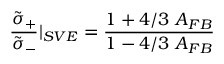Convert formula to latex. <formula><loc_0><loc_0><loc_500><loc_500>{ \frac { \tilde { \sigma } _ { + } } { \tilde { \sigma } _ { - } } } | _ { S V E } = { \frac { 1 + 4 / 3 \ A _ { F B } } { 1 - 4 / 3 \ A _ { F B } } }</formula> 